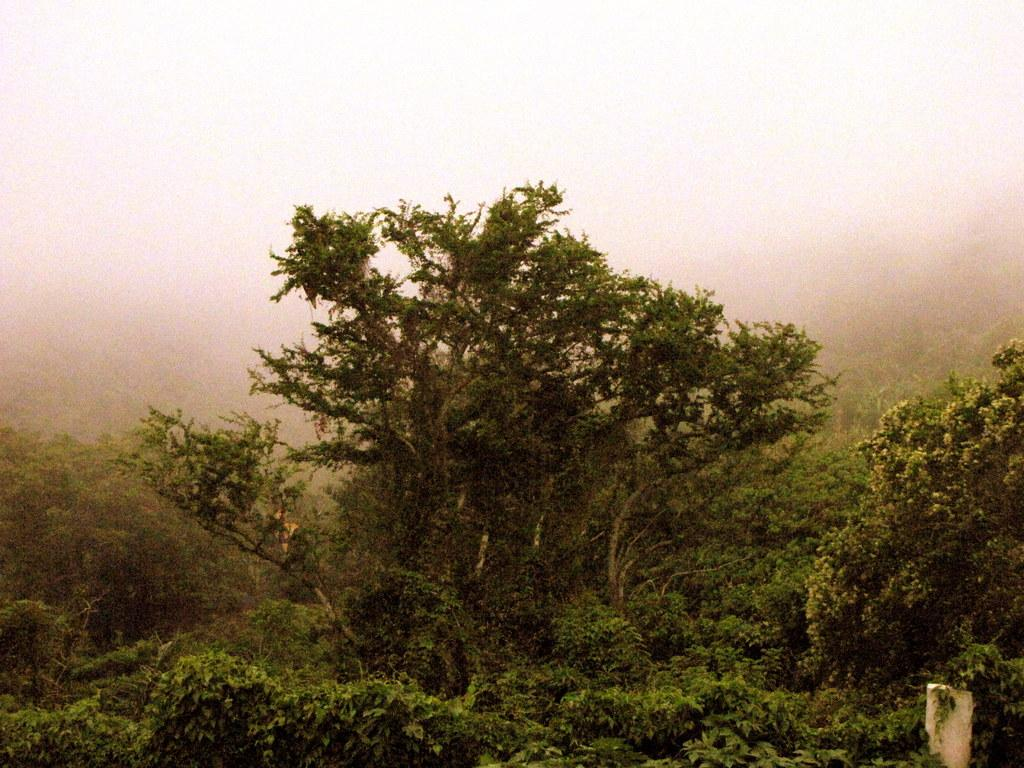What type of vegetation can be seen in the image? There are many trees, plants, and grass visible in the image. Where is the wall located in the image? The wall is in the bottom right corner of the image. What is the weather condition in the image? The presence of fog in the background suggests a foggy or misty condition. How many books can be seen in the image? There are no books present in the image. 